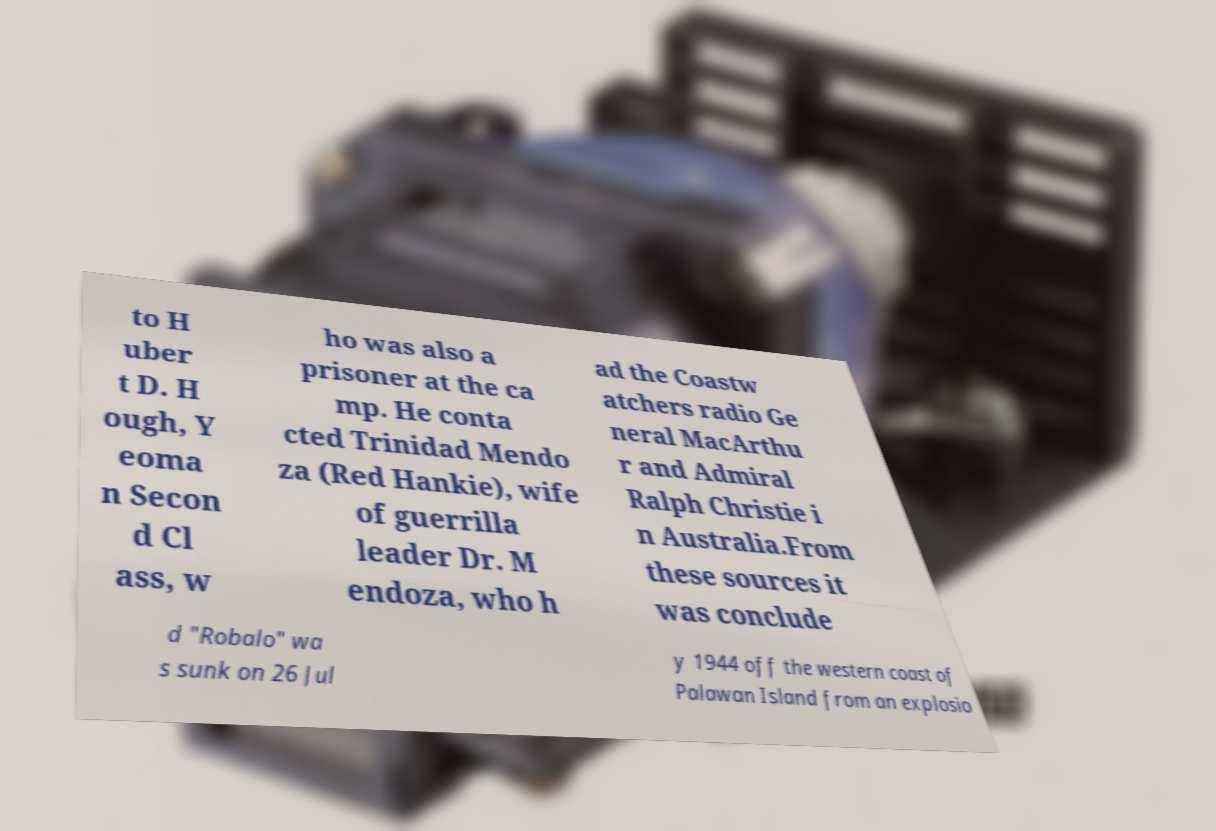Please read and relay the text visible in this image. What does it say? to H uber t D. H ough, Y eoma n Secon d Cl ass, w ho was also a prisoner at the ca mp. He conta cted Trinidad Mendo za (Red Hankie), wife of guerrilla leader Dr. M endoza, who h ad the Coastw atchers radio Ge neral MacArthu r and Admiral Ralph Christie i n Australia.From these sources it was conclude d "Robalo" wa s sunk on 26 Jul y 1944 off the western coast of Palawan Island from an explosio 